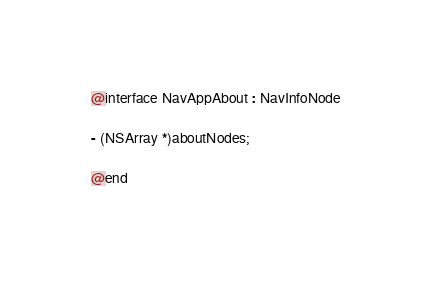<code> <loc_0><loc_0><loc_500><loc_500><_C_>
@interface NavAppAbout : NavInfoNode

- (NSArray *)aboutNodes;

@end
</code> 